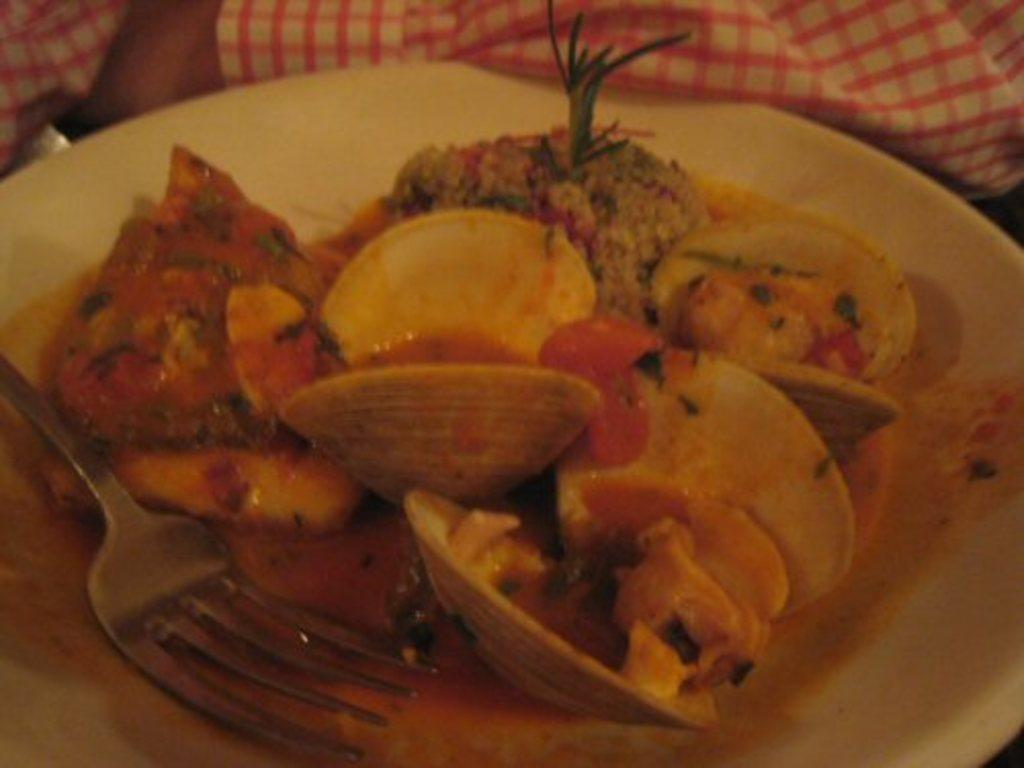What is placed on the table in the image? There are eatable things placed on a table in the image. What utensils can be seen in the image? There are spoons visible in the image. What type of material is present on the table in the image? There is cloth present in the image. What is the name of the town where the lunchroom is located in the image? There is no town or lunchroom present in the image; it only features eatable things, spoons, and cloth on a table. 